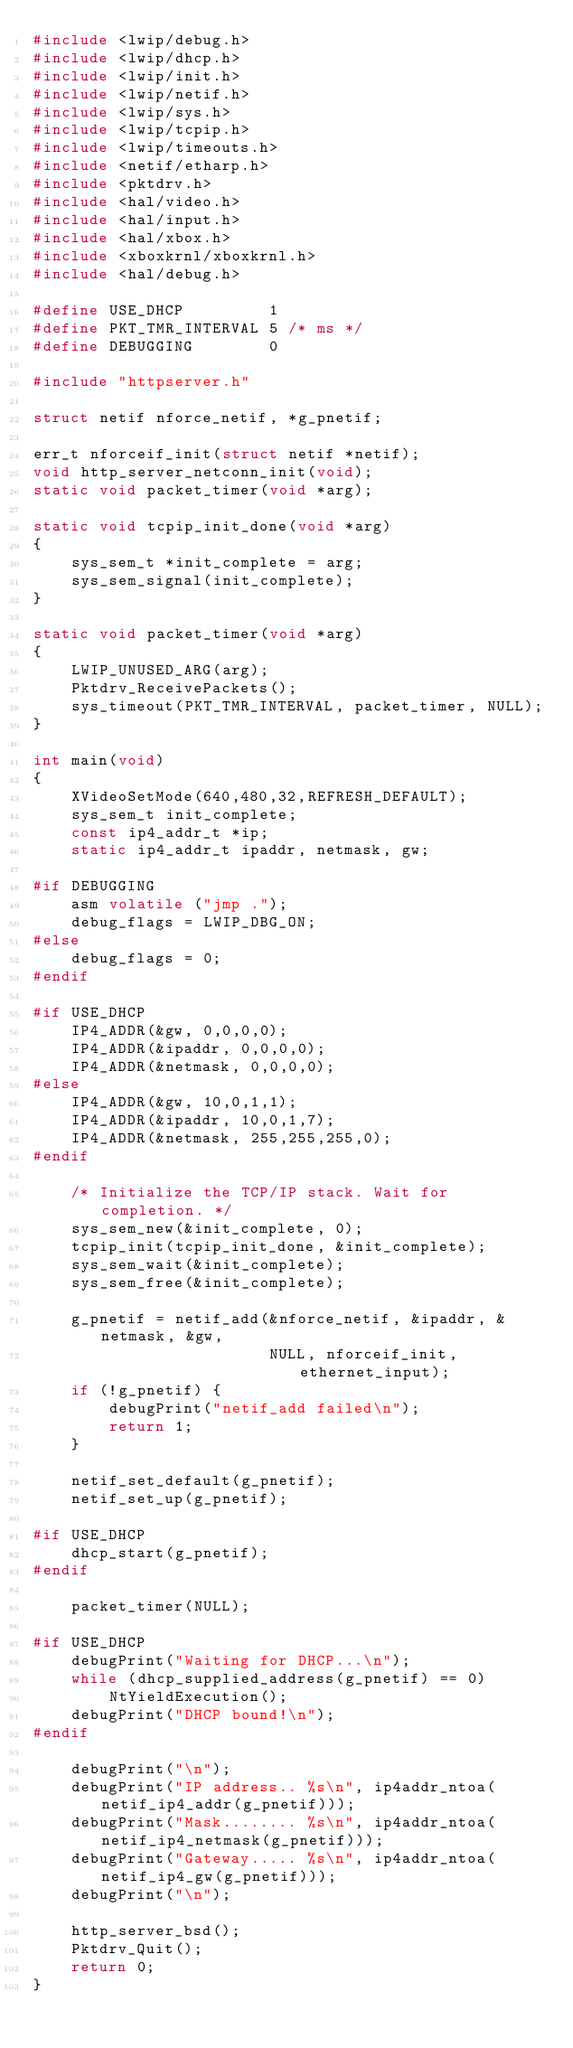<code> <loc_0><loc_0><loc_500><loc_500><_C_>#include <lwip/debug.h>
#include <lwip/dhcp.h>
#include <lwip/init.h>
#include <lwip/netif.h>
#include <lwip/sys.h>
#include <lwip/tcpip.h>
#include <lwip/timeouts.h>
#include <netif/etharp.h>
#include <pktdrv.h>
#include <hal/video.h>
#include <hal/input.h>
#include <hal/xbox.h>
#include <xboxkrnl/xboxkrnl.h>
#include <hal/debug.h>

#define USE_DHCP         1
#define PKT_TMR_INTERVAL 5 /* ms */
#define DEBUGGING        0

#include "httpserver.h"

struct netif nforce_netif, *g_pnetif;

err_t nforceif_init(struct netif *netif);
void http_server_netconn_init(void);
static void packet_timer(void *arg);

static void tcpip_init_done(void *arg)
{
    sys_sem_t *init_complete = arg;
    sys_sem_signal(init_complete);
}

static void packet_timer(void *arg)
{
    LWIP_UNUSED_ARG(arg);
    Pktdrv_ReceivePackets();
    sys_timeout(PKT_TMR_INTERVAL, packet_timer, NULL);
}

int main(void)
{
    XVideoSetMode(640,480,32,REFRESH_DEFAULT);
    sys_sem_t init_complete;
    const ip4_addr_t *ip;
    static ip4_addr_t ipaddr, netmask, gw;

#if DEBUGGING
    asm volatile ("jmp .");
    debug_flags = LWIP_DBG_ON;
#else
    debug_flags = 0;
#endif

#if USE_DHCP
    IP4_ADDR(&gw, 0,0,0,0);
    IP4_ADDR(&ipaddr, 0,0,0,0);
    IP4_ADDR(&netmask, 0,0,0,0);
#else
    IP4_ADDR(&gw, 10,0,1,1);
    IP4_ADDR(&ipaddr, 10,0,1,7);
    IP4_ADDR(&netmask, 255,255,255,0);
#endif

    /* Initialize the TCP/IP stack. Wait for completion. */
    sys_sem_new(&init_complete, 0);
    tcpip_init(tcpip_init_done, &init_complete);
    sys_sem_wait(&init_complete);
    sys_sem_free(&init_complete);

    g_pnetif = netif_add(&nforce_netif, &ipaddr, &netmask, &gw,
                         NULL, nforceif_init, ethernet_input);
    if (!g_pnetif) {
        debugPrint("netif_add failed\n");
        return 1;
    }

    netif_set_default(g_pnetif);
    netif_set_up(g_pnetif);

#if USE_DHCP
    dhcp_start(g_pnetif);
#endif

    packet_timer(NULL);

#if USE_DHCP
    debugPrint("Waiting for DHCP...\n");
    while (dhcp_supplied_address(g_pnetif) == 0)
        NtYieldExecution();
    debugPrint("DHCP bound!\n");
#endif

    debugPrint("\n");
    debugPrint("IP address.. %s\n", ip4addr_ntoa(netif_ip4_addr(g_pnetif)));
    debugPrint("Mask........ %s\n", ip4addr_ntoa(netif_ip4_netmask(g_pnetif)));
    debugPrint("Gateway..... %s\n", ip4addr_ntoa(netif_ip4_gw(g_pnetif)));
    debugPrint("\n");

    http_server_bsd();
    Pktdrv_Quit();
    return 0;
}
</code> 